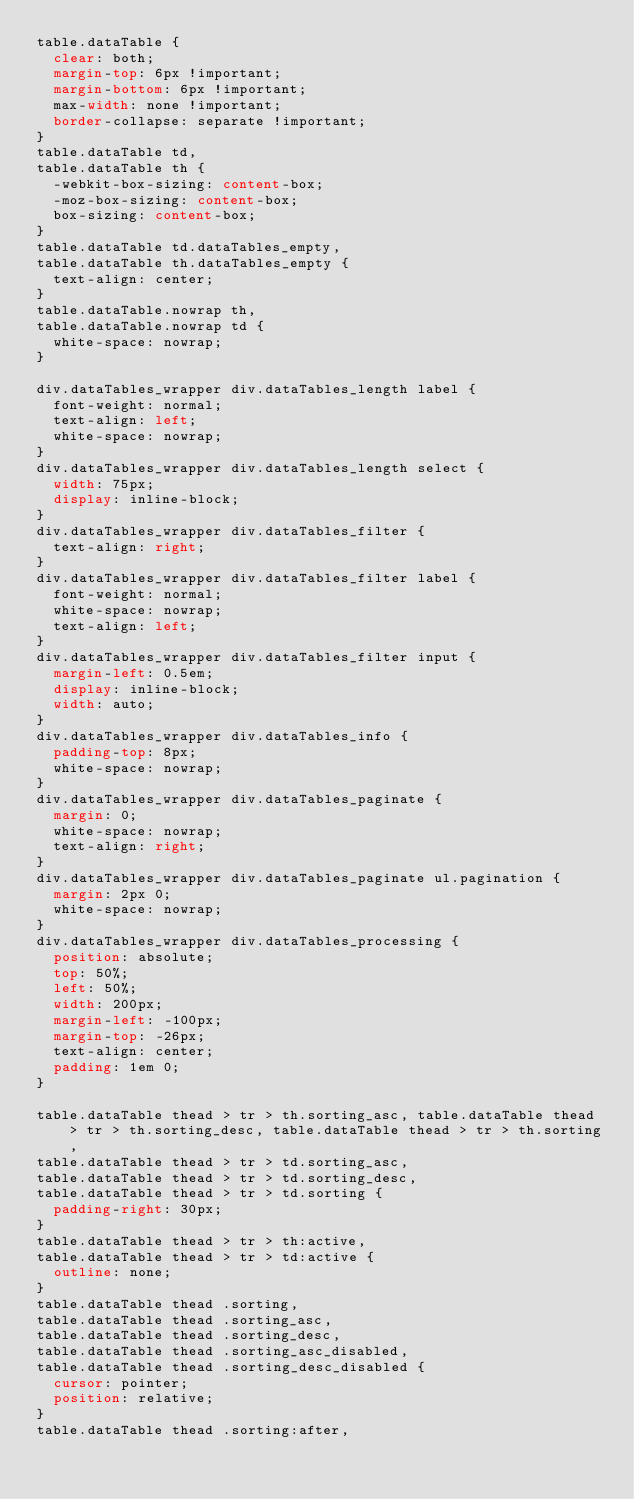Convert code to text. <code><loc_0><loc_0><loc_500><loc_500><_CSS_>table.dataTable {
  clear: both;
  margin-top: 6px !important;
  margin-bottom: 6px !important;
  max-width: none !important;
  border-collapse: separate !important;
}
table.dataTable td,
table.dataTable th {
  -webkit-box-sizing: content-box;
  -moz-box-sizing: content-box;
  box-sizing: content-box;
}
table.dataTable td.dataTables_empty,
table.dataTable th.dataTables_empty {
  text-align: center;
}
table.dataTable.nowrap th,
table.dataTable.nowrap td {
  white-space: nowrap;
}

div.dataTables_wrapper div.dataTables_length label {
  font-weight: normal;
  text-align: left;
  white-space: nowrap;
}
div.dataTables_wrapper div.dataTables_length select {
  width: 75px;
  display: inline-block;
}
div.dataTables_wrapper div.dataTables_filter {
  text-align: right;
}
div.dataTables_wrapper div.dataTables_filter label {
  font-weight: normal;
  white-space: nowrap;
  text-align: left;
}
div.dataTables_wrapper div.dataTables_filter input {
  margin-left: 0.5em;
  display: inline-block;
  width: auto;
}
div.dataTables_wrapper div.dataTables_info {
  padding-top: 8px;
  white-space: nowrap;
}
div.dataTables_wrapper div.dataTables_paginate {
  margin: 0;
  white-space: nowrap;
  text-align: right;
}
div.dataTables_wrapper div.dataTables_paginate ul.pagination {
  margin: 2px 0;
  white-space: nowrap;
}
div.dataTables_wrapper div.dataTables_processing {
  position: absolute;
  top: 50%;
  left: 50%;
  width: 200px;
  margin-left: -100px;
  margin-top: -26px;
  text-align: center;
  padding: 1em 0;
}

table.dataTable thead > tr > th.sorting_asc, table.dataTable thead > tr > th.sorting_desc, table.dataTable thead > tr > th.sorting,
table.dataTable thead > tr > td.sorting_asc,
table.dataTable thead > tr > td.sorting_desc,
table.dataTable thead > tr > td.sorting {
  padding-right: 30px;
}
table.dataTable thead > tr > th:active,
table.dataTable thead > tr > td:active {
  outline: none;
}
table.dataTable thead .sorting,
table.dataTable thead .sorting_asc,
table.dataTable thead .sorting_desc,
table.dataTable thead .sorting_asc_disabled,
table.dataTable thead .sorting_desc_disabled {
  cursor: pointer;
  position: relative;
}
table.dataTable thead .sorting:after,</code> 